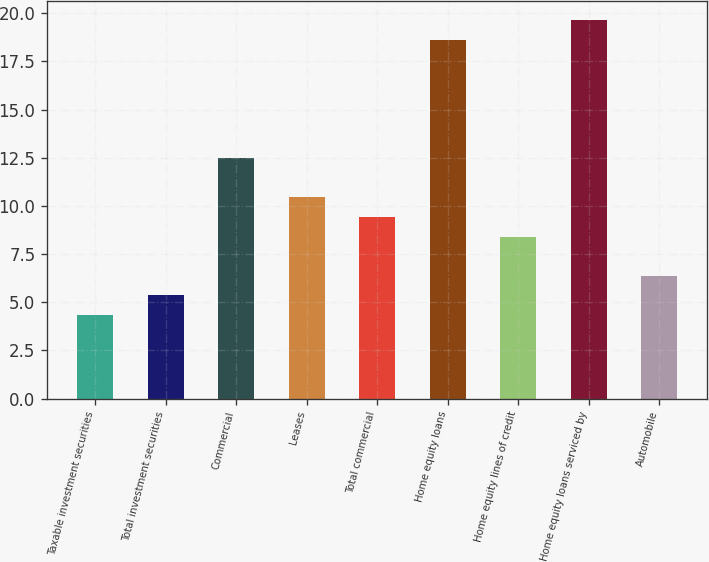Convert chart. <chart><loc_0><loc_0><loc_500><loc_500><bar_chart><fcel>Taxable investment securities<fcel>Total investment securities<fcel>Commercial<fcel>Leases<fcel>Total commercial<fcel>Home equity loans<fcel>Home equity lines of credit<fcel>Home equity loans serviced by<fcel>Automobile<nl><fcel>4.33<fcel>5.35<fcel>12.49<fcel>10.45<fcel>9.43<fcel>18.61<fcel>8.41<fcel>19.63<fcel>6.37<nl></chart> 